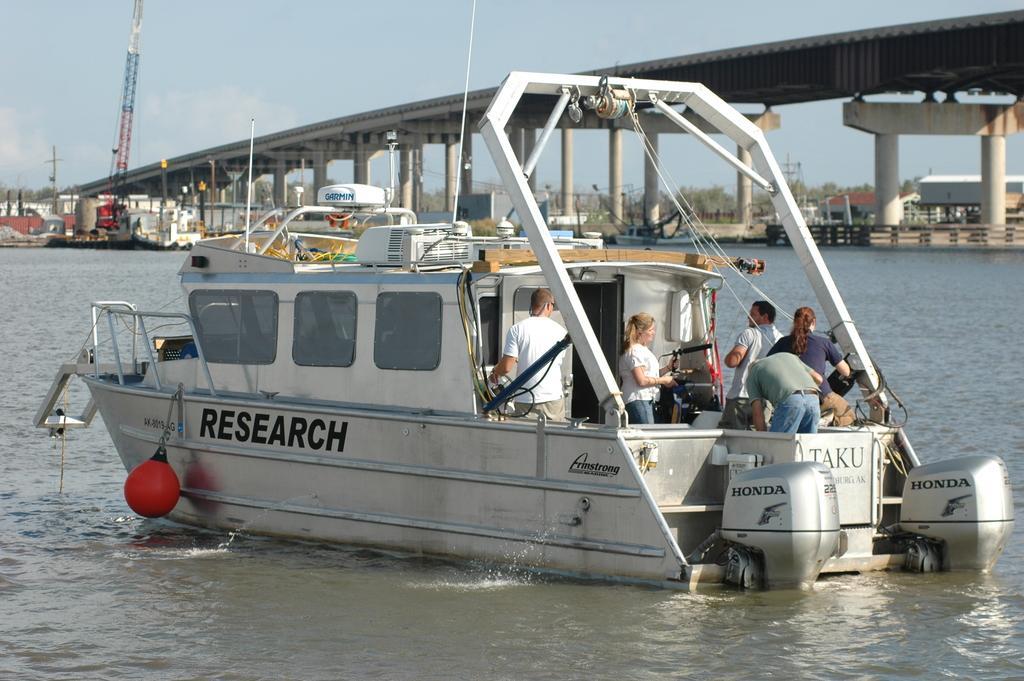Could you give a brief overview of what you see in this image? In this picture we can see a group of people in the boat and the boat is on the water. Behind the boat, there are trees, a crane, bridge, a pole, building and some objects. At the top of the image, there is the sky. 